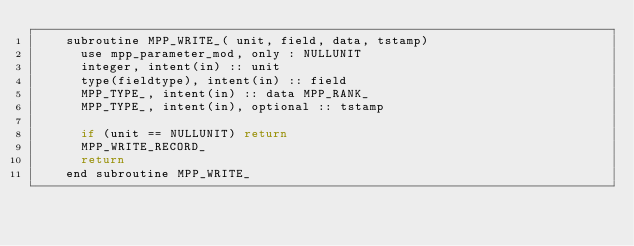Convert code to text. <code><loc_0><loc_0><loc_500><loc_500><_C_>    subroutine MPP_WRITE_( unit, field, data, tstamp)
      use mpp_parameter_mod, only : NULLUNIT
      integer, intent(in) :: unit
      type(fieldtype), intent(in) :: field
      MPP_TYPE_, intent(in) :: data MPP_RANK_
      MPP_TYPE_, intent(in), optional :: tstamp

      if (unit == NULLUNIT) return
      MPP_WRITE_RECORD_
      return
    end subroutine MPP_WRITE_
</code> 